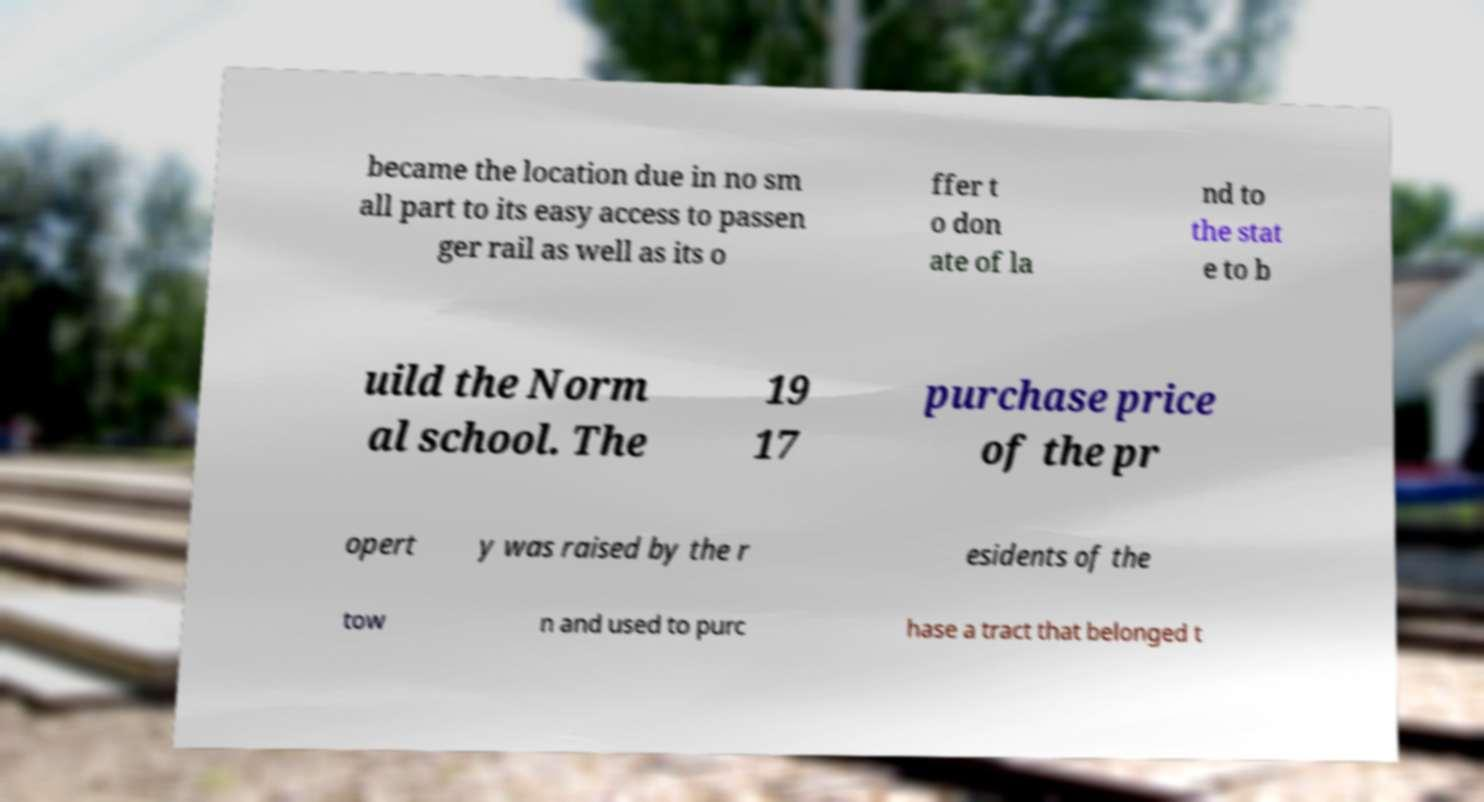What messages or text are displayed in this image? I need them in a readable, typed format. became the location due in no sm all part to its easy access to passen ger rail as well as its o ffer t o don ate of la nd to the stat e to b uild the Norm al school. The 19 17 purchase price of the pr opert y was raised by the r esidents of the tow n and used to purc hase a tract that belonged t 